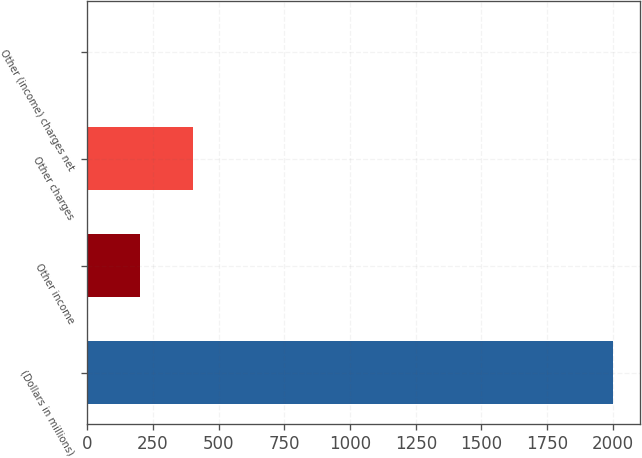Convert chart to OTSL. <chart><loc_0><loc_0><loc_500><loc_500><bar_chart><fcel>(Dollars in millions)<fcel>Other income<fcel>Other charges<fcel>Other (income) charges net<nl><fcel>2002<fcel>202<fcel>402<fcel>2<nl></chart> 